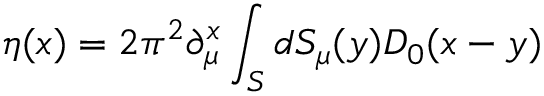<formula> <loc_0><loc_0><loc_500><loc_500>\eta ( x ) = 2 \pi ^ { 2 } \partial _ { \mu } ^ { x } \int _ { S } d S _ { \mu } ( y ) D _ { 0 } ( x - y )</formula> 